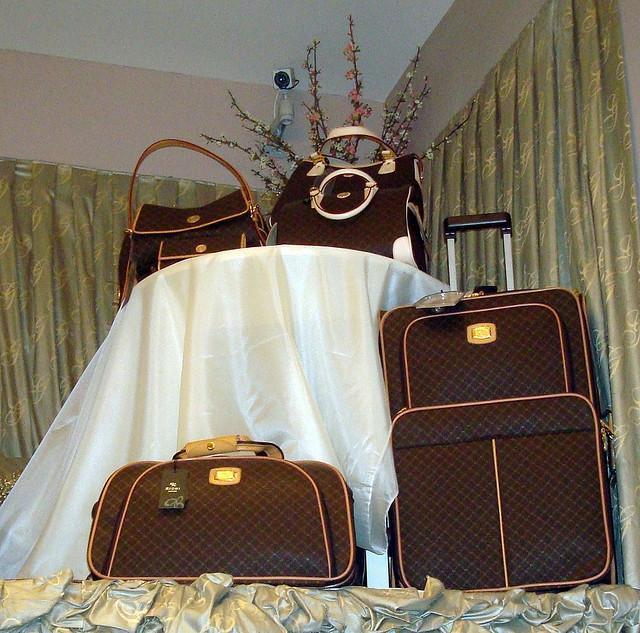How many pieces of luggage is there?
Give a very brief answer. 4. How many handbags are there?
Give a very brief answer. 3. 